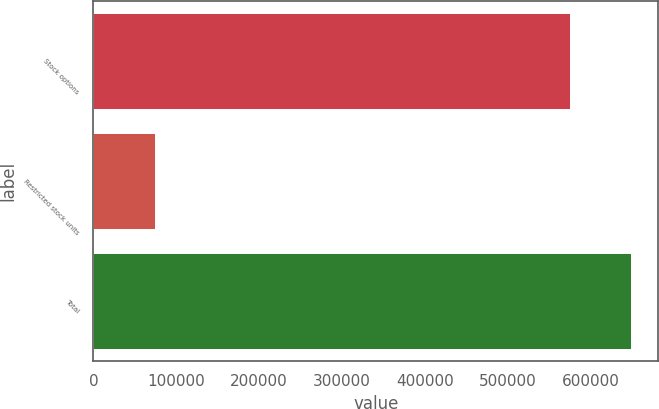Convert chart to OTSL. <chart><loc_0><loc_0><loc_500><loc_500><bar_chart><fcel>Stock options<fcel>Restricted stock units<fcel>Total<nl><fcel>575266<fcel>74166<fcel>649432<nl></chart> 